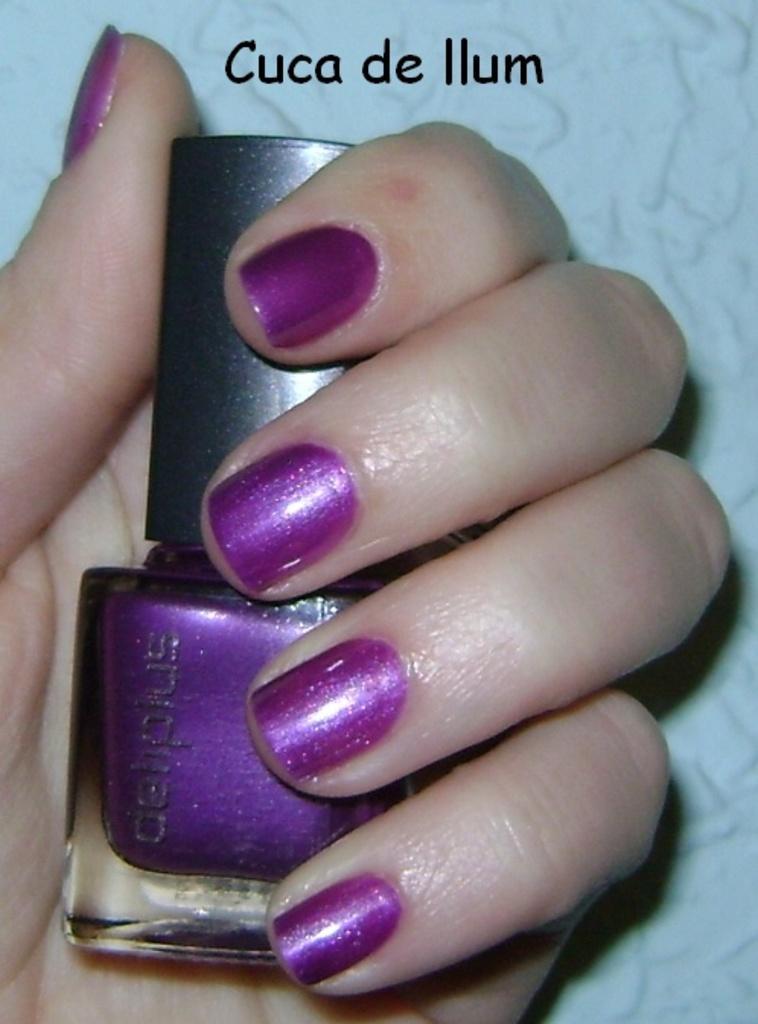Describe this image in one or two sentences. In this picture I can see a nail polish bottle in the human hand and I can see text at the top of the picture. 